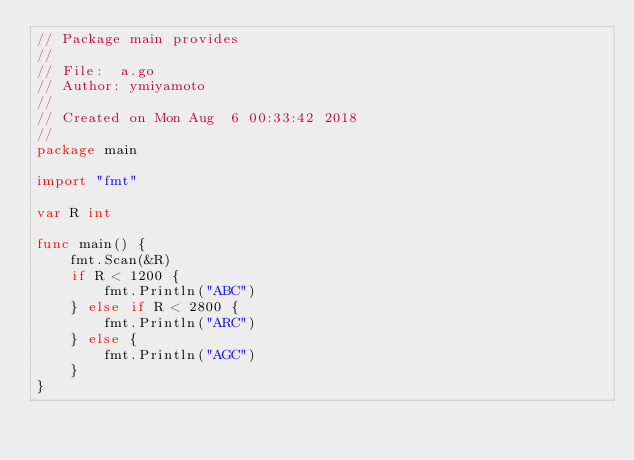Convert code to text. <code><loc_0><loc_0><loc_500><loc_500><_Go_>// Package main provides
//
// File:  a.go
// Author: ymiyamoto
//
// Created on Mon Aug  6 00:33:42 2018
//
package main

import "fmt"

var R int

func main() {
	fmt.Scan(&R)
	if R < 1200 {
		fmt.Println("ABC")
	} else if R < 2800 {
		fmt.Println("ARC")
	} else {
		fmt.Println("AGC")
	}
}
</code> 